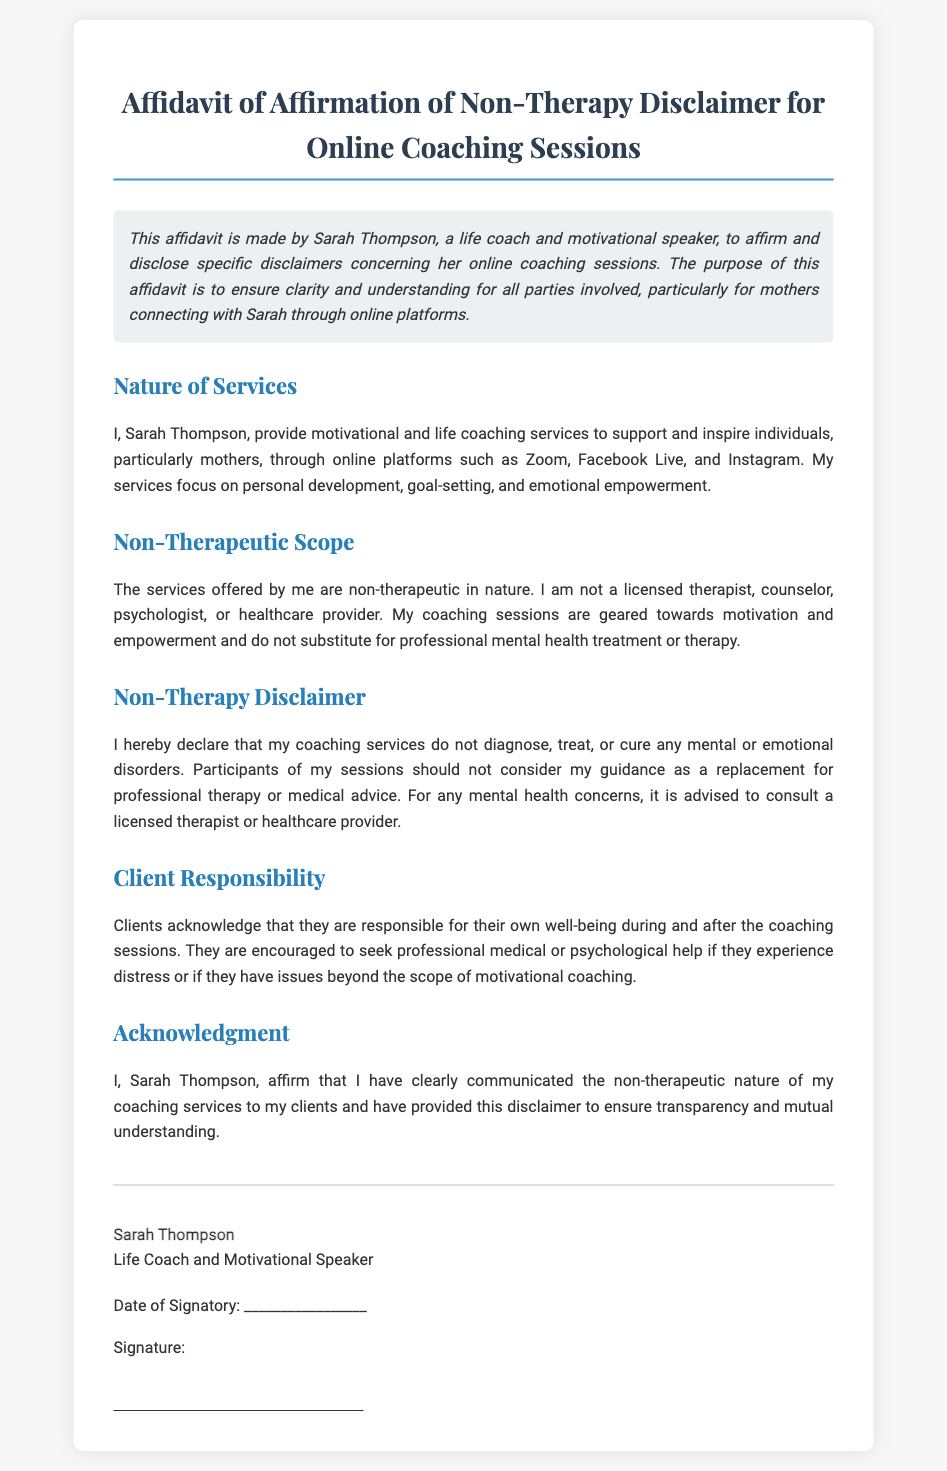What is the name of the life coach? The document specifies the name of the life coach as Sarah Thompson.
Answer: Sarah Thompson What type of coaching services does Sarah provide? The services described in the document focus on personal development, goal-setting, and emotional empowerment.
Answer: Motivational and life coaching Is Sarah Thompson a licensed therapist? The document clearly states that she is not a licensed therapist, counselor, psychologist, or healthcare provider.
Answer: No What platforms are mentioned for online coaching sessions? The affidavit mentions platforms such as Zoom, Facebook Live, and Instagram for coaching.
Answer: Zoom, Facebook Live, Instagram What should clients do if they have mental health concerns? The document advises clients to consult a licensed therapist or healthcare provider for mental health issues.
Answer: Consult a licensed therapist In which section is the non-therapeutic nature of services discussed? The document discusses the non-therapeutic nature of services under the "Non-Therapeutic Scope" section.
Answer: Non-Therapeutic Scope What is the date of the signatory indicated as? This field is left blank for the signatory to fill in.
Answer: _________________ What does the acknowledgment section affirm? It affirms that Sarah has communicated the non-therapeutic nature of her services to her clients.
Answer: Non-therapeutic nature communicated What responsibility do clients have during the coaching sessions? Clients acknowledge their responsibility for their own well-being during and after the coaching sessions.
Answer: Client responsibility 